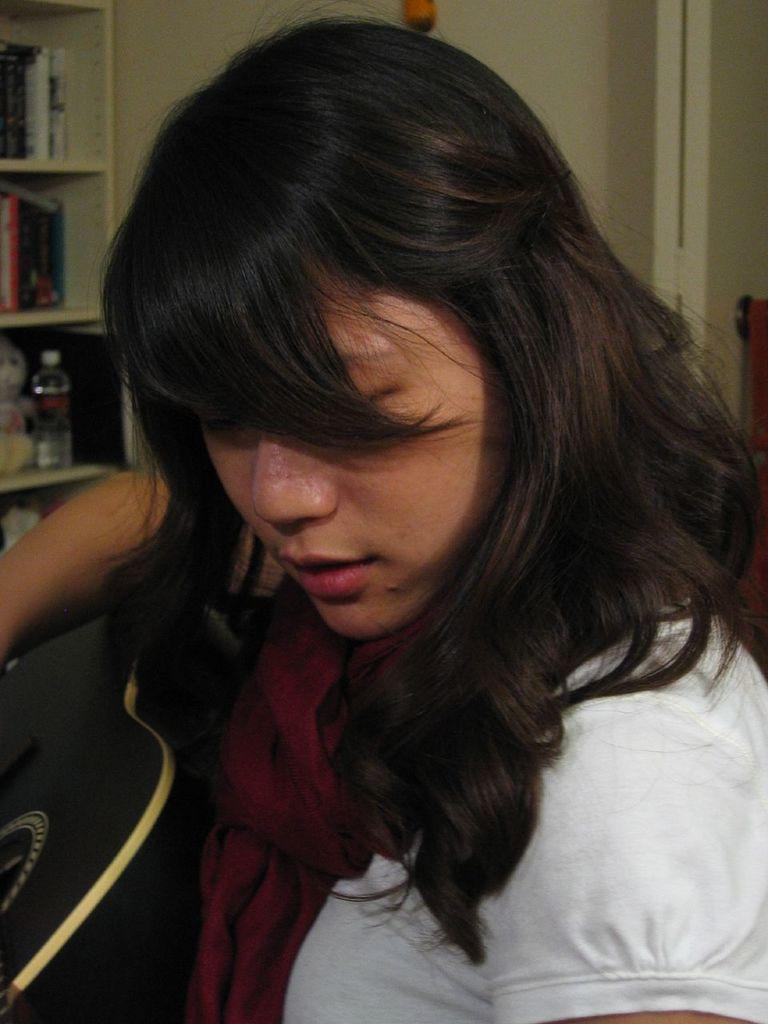What is the person in the image wearing? The person is wearing a white dress. What is the person holding in the image? The person is holding a guitar. What can be seen in the background of the image? There is a bottle, a toy, and books in a cupboard in the background of the image. How many caps are visible in the image? There are no caps present in the image. What type of knowledge can be gained from the fifth book in the cupboard? There is no indication of the content of the books in the cupboard, and the image does not specify which book is the fifth one. 